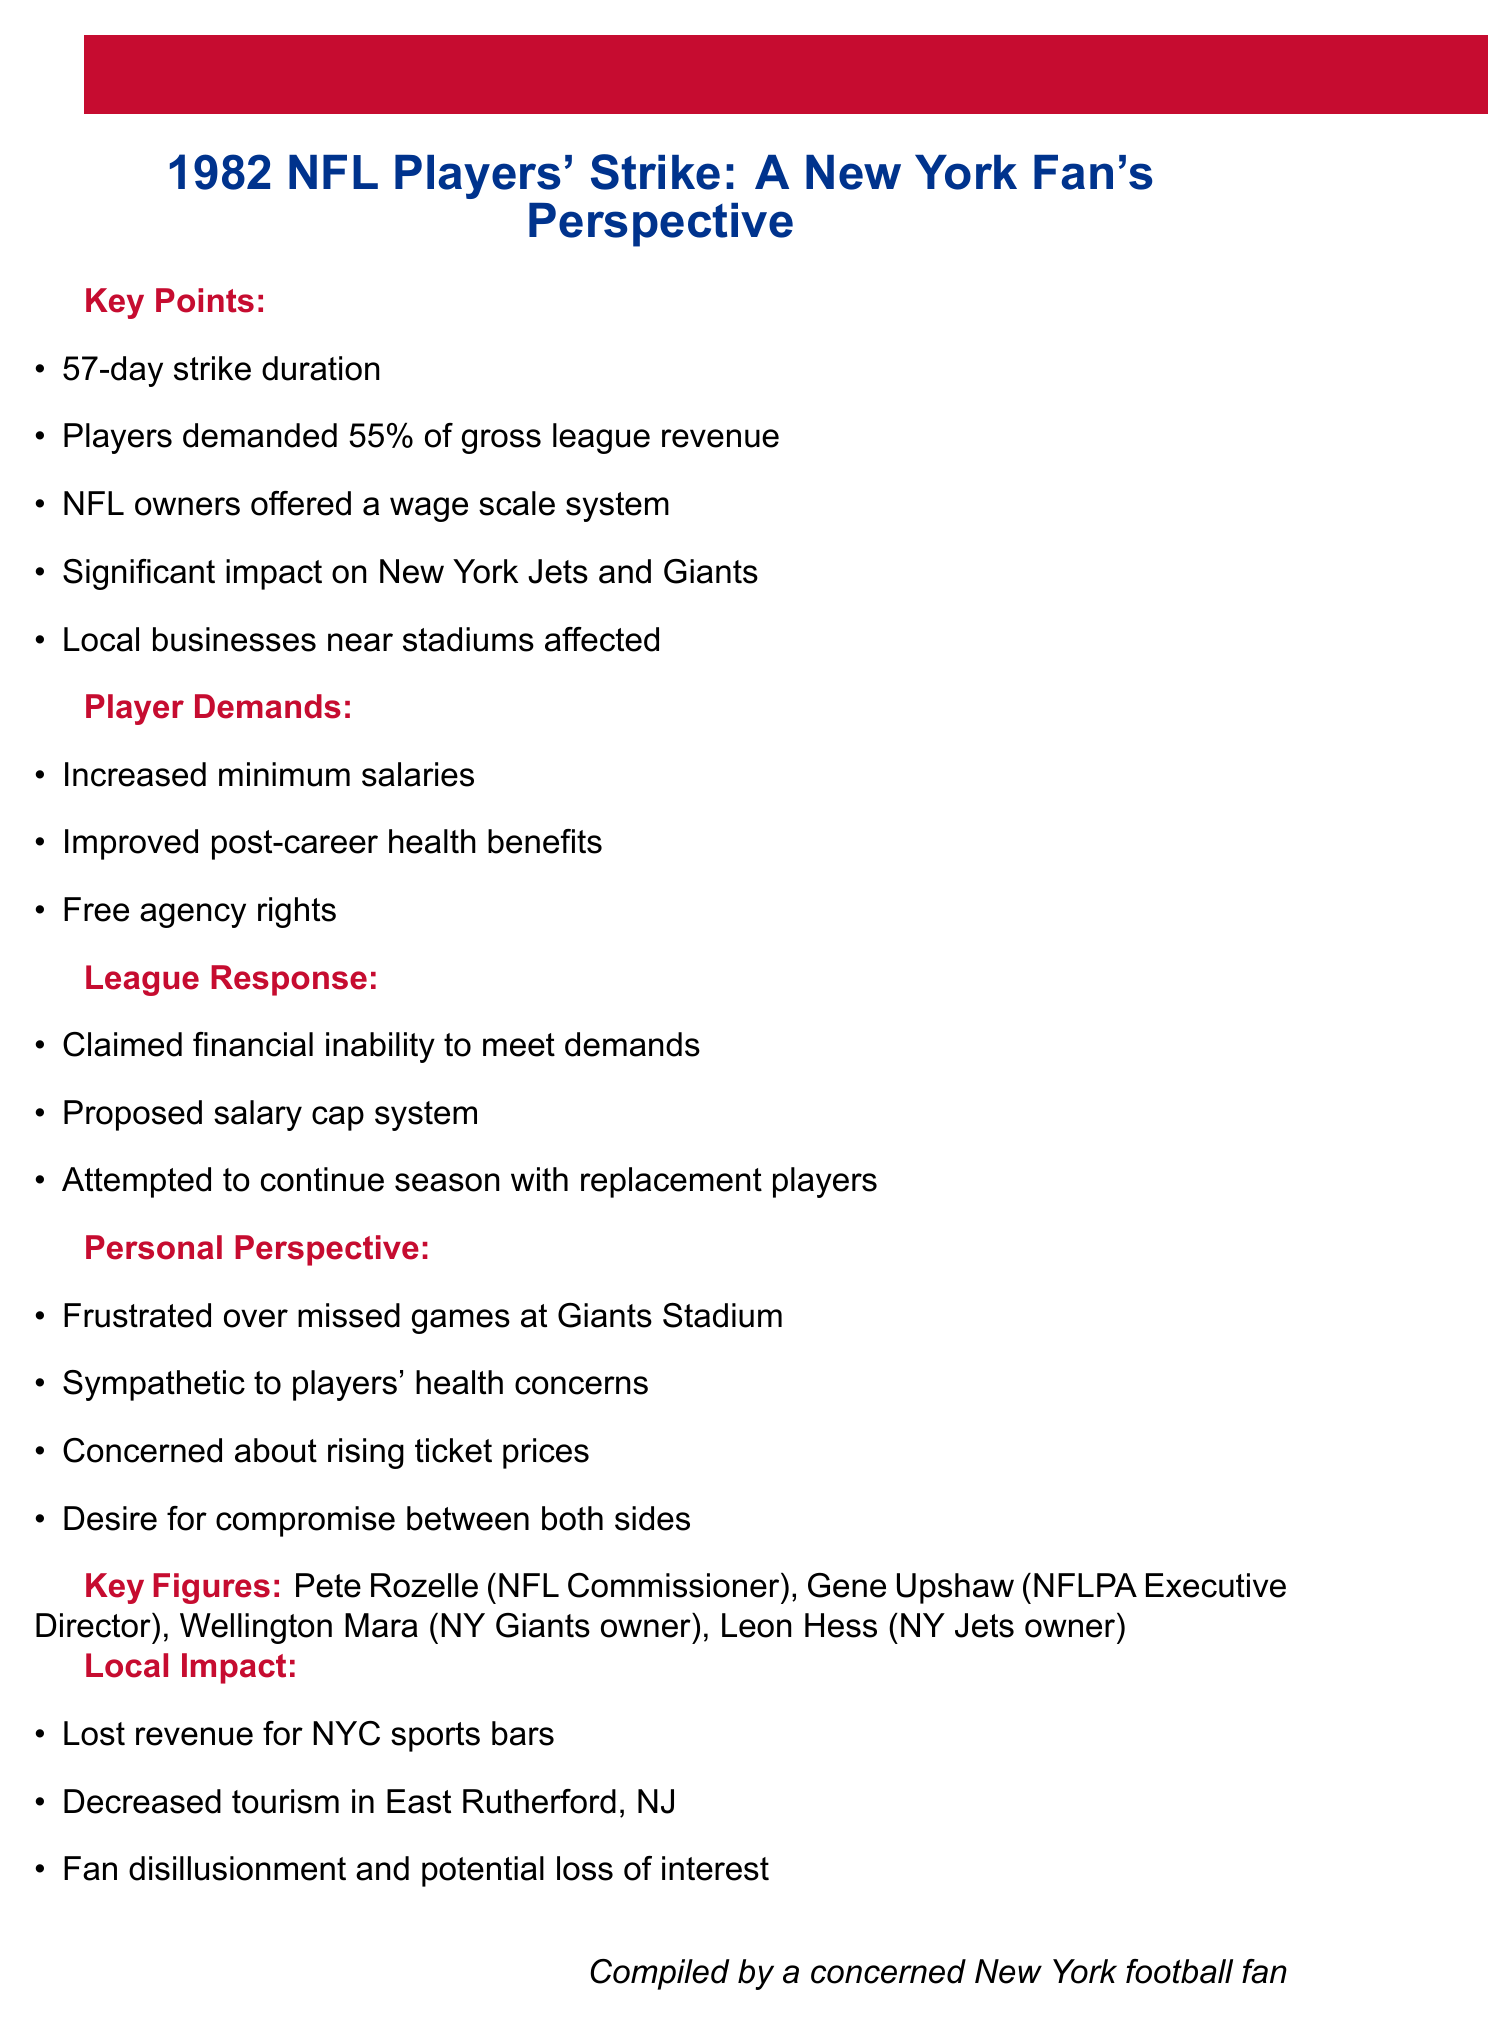What was the duration of the 1982 NFL players' strike? The duration of the strike is stated directly in the document as 57 days.
Answer: 57 days What percentage of gross league revenue did players demand? The document specifies that players demanded 55% of gross league revenue.
Answer: 55% Who is the NFL Commissioner mentioned in the document? The document lists Pete Rozelle as the NFL Commissioner.
Answer: Pete Rozelle What was one player demand mentioned in the document? The document provides several player demands, including improved post-career health benefits.
Answer: Improved post-career health benefits What was the league's response regarding financial capability? The league claimed financial inability to meet player demands.
Answer: Financial inability How did the strike affect local businesses? The document mentions lost revenue for NYC sports bars as a local impact of the strike.
Answer: Lost revenue for NYC sports bars What solution did the league propose in response to player demands? The league proposed a salary cap system as a response.
Answer: Salary cap system What feeling does the author express towards rising ticket prices? The author expresses concern about rising ticket prices.
Answer: Concern What was the reaction of fans during the strike? The document indicates fan disillusionment and potential loss of interest as a reaction.
Answer: Fan disillusionment 